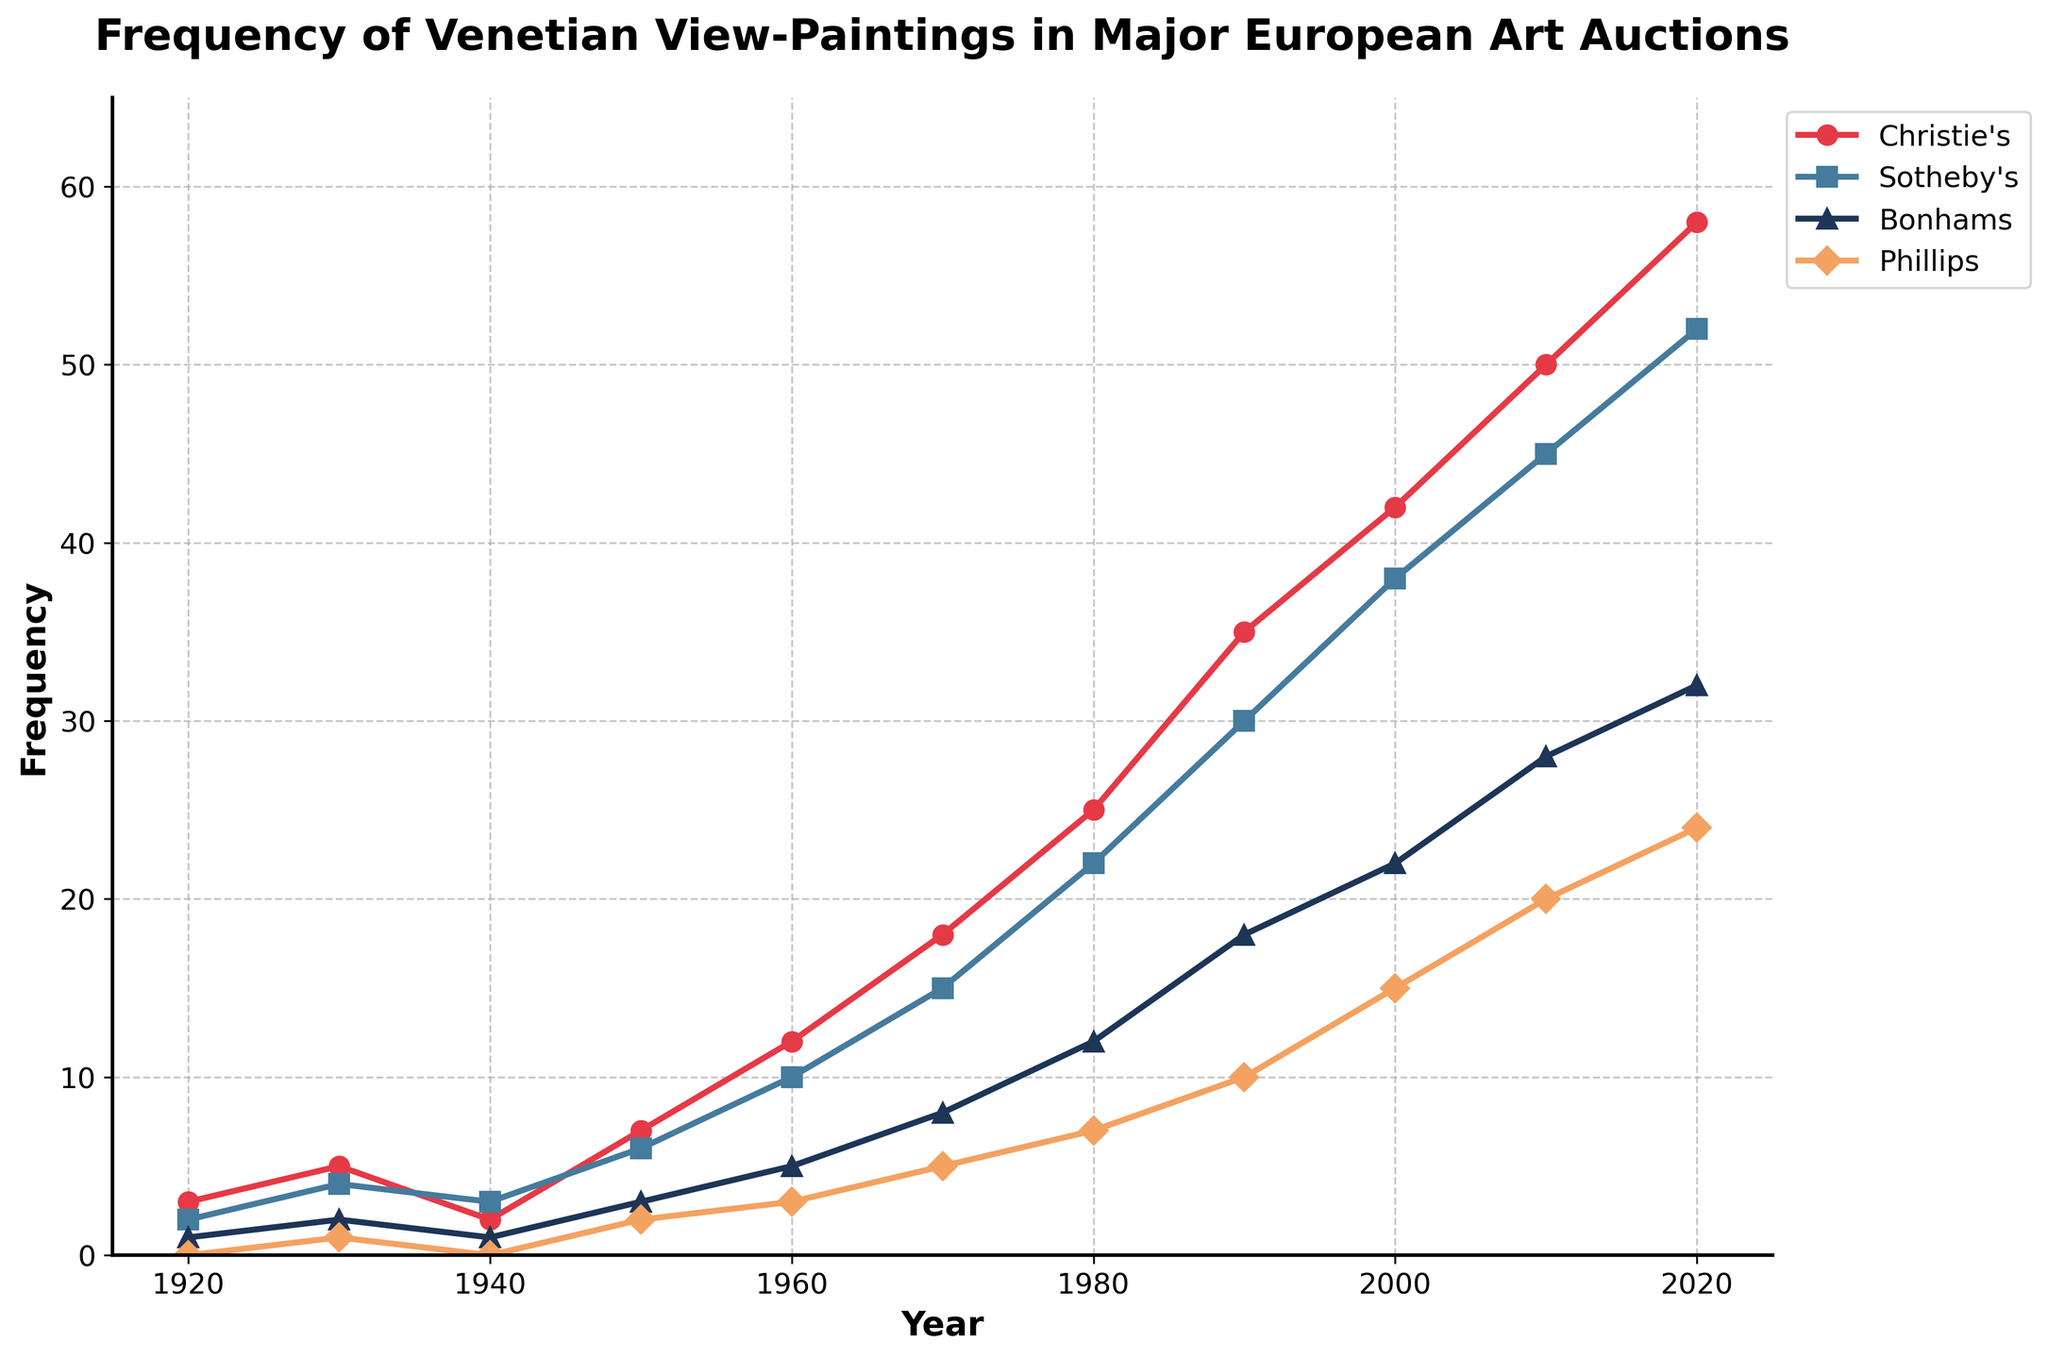What is the difference in the number of Venetian view-paintings auctioned by Christie’s between 1930 and 1950? From the figure, Christie’s auctioned 5 paintings in 1930 and 7 paintings in 1950. The difference is 7 - 5 = 2.
Answer: 2 Between which decades did Sotheby’s see the highest increase in the frequency of Venetian view-paintings auctioned? Observing the figure, the frequency increases from 45 in 2010 to 52 in 2020, which is an increase of 52 - 45 = 7. This is the highest increase compared to other decade intervals.
Answer: 2010 to 2020 Which auction house had the lowest frequency of Venetian view-paintings in 1970? By referring to the figure, in 1970, Phillips auctioned the fewest paintings, with a frequency of 5 paintings.
Answer: Phillips Compare the number of Venetian view-paintings auctioned by Christie’s in 2020 with the combined total of Bonhams and Phillips in the same year. In 2020, Christie’s auctioned 58 paintings. Bonhams and Phillips together auctioned 32 + 24 = 56 paintings.
Answer: Christie’s What is the average number of Venetian view-paintings auctioned by Christie's and Sotheby’s in 1960? In 1960, Christie’s auctioned 12 paintings and Sotheby’s auctioned 10. The average is (12 + 10) / 2 = 11.
Answer: 11 Which auction house shows the steepest increase in the frequency of Venetian view-paintings auctioned from 1980 to 1990? From the figure, Christie’s frequency increased from 25 in 1980 to 35 in 1990, an increase of 35 - 25 = 10. Sotheby’s increased from 22 to 30, Bonhams from 12 to 18, and Phillips from 7 to 10. Christie’s shows the steepest increase.
Answer: Christie’s How many more Venetian view-paintings did Bonhams auction in 2020 compared to 1930? Bonhams auctioned 32 paintings in 2020 and 2 in 1930. The difference is 32 - 2 = 30.
Answer: 30 In which year did Phillips auction exactly half the number of Venetian view-paintings compared to Christie’s in that same year? Referring to the figure, in 1950, Christie’s auctioned 7 paintings and Phillips auctioned 2 paintings, which is not exactly half. Following through, in 1960, 12 and 3 is also not half. Similarly, in 1970, 18 and 5 is a bit off. By 1980, Phillips auctioned 7 against Christie’s 25, which is still not half. In 2000, Phillips auctioned 15, which is not half of 42. Finally, in 2020, Phillips auctioned 24 paintings while Christie’s had 58, and 24 is close but not half. None of the years illustrate a case of Phillips auctioning exactly half the number of paintings compared to Christie’s.
Answer: None 